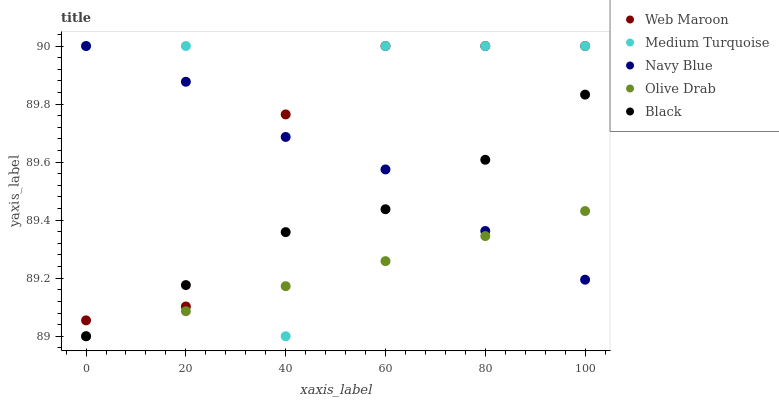Does Olive Drab have the minimum area under the curve?
Answer yes or no. Yes. Does Medium Turquoise have the maximum area under the curve?
Answer yes or no. Yes. Does Web Maroon have the minimum area under the curve?
Answer yes or no. No. Does Web Maroon have the maximum area under the curve?
Answer yes or no. No. Is Olive Drab the smoothest?
Answer yes or no. Yes. Is Medium Turquoise the roughest?
Answer yes or no. Yes. Is Web Maroon the smoothest?
Answer yes or no. No. Is Web Maroon the roughest?
Answer yes or no. No. Does Olive Drab have the lowest value?
Answer yes or no. Yes. Does Web Maroon have the lowest value?
Answer yes or no. No. Does Medium Turquoise have the highest value?
Answer yes or no. Yes. Does Olive Drab have the highest value?
Answer yes or no. No. Is Olive Drab less than Web Maroon?
Answer yes or no. Yes. Is Web Maroon greater than Olive Drab?
Answer yes or no. Yes. Does Olive Drab intersect Black?
Answer yes or no. Yes. Is Olive Drab less than Black?
Answer yes or no. No. Is Olive Drab greater than Black?
Answer yes or no. No. Does Olive Drab intersect Web Maroon?
Answer yes or no. No. 